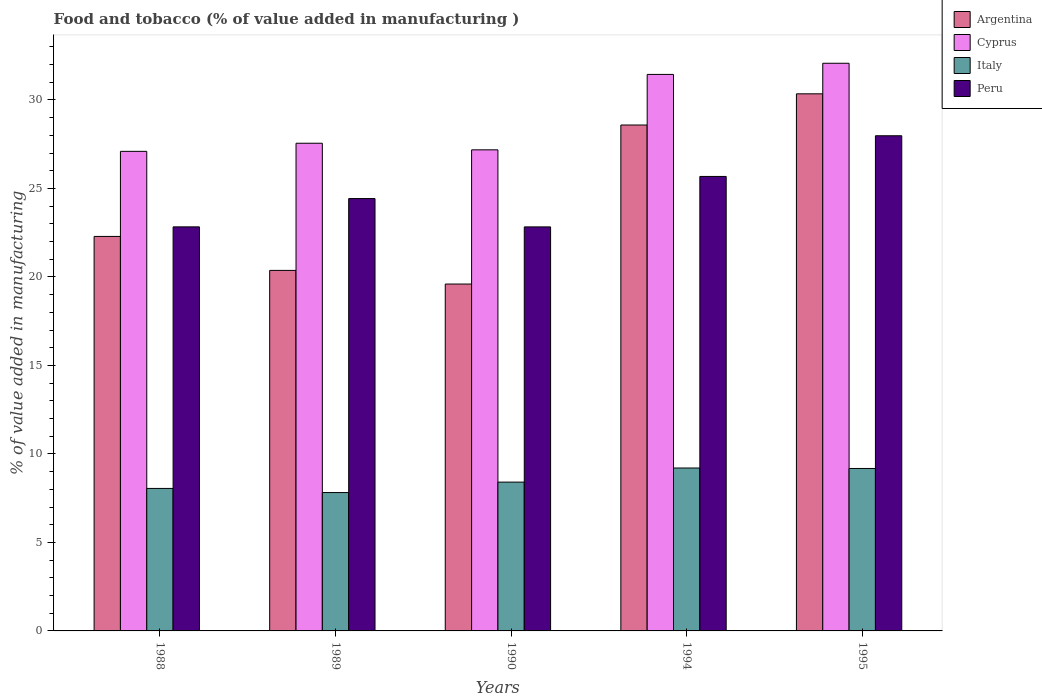How many groups of bars are there?
Your answer should be very brief. 5. Are the number of bars per tick equal to the number of legend labels?
Provide a succinct answer. Yes. Are the number of bars on each tick of the X-axis equal?
Provide a succinct answer. Yes. In how many cases, is the number of bars for a given year not equal to the number of legend labels?
Provide a short and direct response. 0. What is the value added in manufacturing food and tobacco in Argentina in 1989?
Provide a succinct answer. 20.37. Across all years, what is the maximum value added in manufacturing food and tobacco in Cyprus?
Provide a succinct answer. 32.07. Across all years, what is the minimum value added in manufacturing food and tobacco in Argentina?
Your response must be concise. 19.6. In which year was the value added in manufacturing food and tobacco in Peru maximum?
Provide a short and direct response. 1995. In which year was the value added in manufacturing food and tobacco in Cyprus minimum?
Your response must be concise. 1988. What is the total value added in manufacturing food and tobacco in Italy in the graph?
Your response must be concise. 42.66. What is the difference between the value added in manufacturing food and tobacco in Cyprus in 1988 and that in 1994?
Make the answer very short. -4.35. What is the difference between the value added in manufacturing food and tobacco in Peru in 1988 and the value added in manufacturing food and tobacco in Cyprus in 1995?
Provide a short and direct response. -9.24. What is the average value added in manufacturing food and tobacco in Cyprus per year?
Make the answer very short. 29.07. In the year 1995, what is the difference between the value added in manufacturing food and tobacco in Italy and value added in manufacturing food and tobacco in Argentina?
Provide a short and direct response. -21.17. What is the ratio of the value added in manufacturing food and tobacco in Cyprus in 1989 to that in 1995?
Your response must be concise. 0.86. What is the difference between the highest and the second highest value added in manufacturing food and tobacco in Cyprus?
Give a very brief answer. 0.63. What is the difference between the highest and the lowest value added in manufacturing food and tobacco in Peru?
Offer a very short reply. 5.15. What does the 1st bar from the left in 1990 represents?
Offer a terse response. Argentina. How many bars are there?
Offer a terse response. 20. Are all the bars in the graph horizontal?
Ensure brevity in your answer.  No. What is the title of the graph?
Ensure brevity in your answer.  Food and tobacco (% of value added in manufacturing ). Does "Rwanda" appear as one of the legend labels in the graph?
Your answer should be compact. No. What is the label or title of the Y-axis?
Keep it short and to the point. % of value added in manufacturing. What is the % of value added in manufacturing in Argentina in 1988?
Your answer should be very brief. 22.29. What is the % of value added in manufacturing in Cyprus in 1988?
Provide a succinct answer. 27.1. What is the % of value added in manufacturing of Italy in 1988?
Offer a terse response. 8.05. What is the % of value added in manufacturing in Peru in 1988?
Make the answer very short. 22.83. What is the % of value added in manufacturing of Argentina in 1989?
Ensure brevity in your answer.  20.37. What is the % of value added in manufacturing of Cyprus in 1989?
Offer a very short reply. 27.56. What is the % of value added in manufacturing of Italy in 1989?
Your answer should be compact. 7.82. What is the % of value added in manufacturing in Peru in 1989?
Keep it short and to the point. 24.43. What is the % of value added in manufacturing in Argentina in 1990?
Offer a very short reply. 19.6. What is the % of value added in manufacturing in Cyprus in 1990?
Provide a succinct answer. 27.18. What is the % of value added in manufacturing in Italy in 1990?
Ensure brevity in your answer.  8.41. What is the % of value added in manufacturing of Peru in 1990?
Provide a short and direct response. 22.83. What is the % of value added in manufacturing in Argentina in 1994?
Make the answer very short. 28.58. What is the % of value added in manufacturing of Cyprus in 1994?
Provide a short and direct response. 31.44. What is the % of value added in manufacturing of Italy in 1994?
Your answer should be very brief. 9.21. What is the % of value added in manufacturing in Peru in 1994?
Offer a terse response. 25.68. What is the % of value added in manufacturing of Argentina in 1995?
Offer a terse response. 30.35. What is the % of value added in manufacturing of Cyprus in 1995?
Your answer should be very brief. 32.07. What is the % of value added in manufacturing of Italy in 1995?
Give a very brief answer. 9.18. What is the % of value added in manufacturing in Peru in 1995?
Make the answer very short. 27.98. Across all years, what is the maximum % of value added in manufacturing of Argentina?
Your response must be concise. 30.35. Across all years, what is the maximum % of value added in manufacturing of Cyprus?
Offer a terse response. 32.07. Across all years, what is the maximum % of value added in manufacturing in Italy?
Offer a terse response. 9.21. Across all years, what is the maximum % of value added in manufacturing of Peru?
Provide a succinct answer. 27.98. Across all years, what is the minimum % of value added in manufacturing of Argentina?
Offer a very short reply. 19.6. Across all years, what is the minimum % of value added in manufacturing in Cyprus?
Offer a very short reply. 27.1. Across all years, what is the minimum % of value added in manufacturing of Italy?
Make the answer very short. 7.82. Across all years, what is the minimum % of value added in manufacturing in Peru?
Provide a succinct answer. 22.83. What is the total % of value added in manufacturing of Argentina in the graph?
Keep it short and to the point. 121.19. What is the total % of value added in manufacturing of Cyprus in the graph?
Your answer should be compact. 145.35. What is the total % of value added in manufacturing of Italy in the graph?
Your response must be concise. 42.66. What is the total % of value added in manufacturing of Peru in the graph?
Make the answer very short. 123.74. What is the difference between the % of value added in manufacturing of Argentina in 1988 and that in 1989?
Your response must be concise. 1.92. What is the difference between the % of value added in manufacturing of Cyprus in 1988 and that in 1989?
Provide a short and direct response. -0.46. What is the difference between the % of value added in manufacturing in Italy in 1988 and that in 1989?
Keep it short and to the point. 0.23. What is the difference between the % of value added in manufacturing of Argentina in 1988 and that in 1990?
Provide a short and direct response. 2.69. What is the difference between the % of value added in manufacturing in Cyprus in 1988 and that in 1990?
Make the answer very short. -0.09. What is the difference between the % of value added in manufacturing of Italy in 1988 and that in 1990?
Give a very brief answer. -0.36. What is the difference between the % of value added in manufacturing in Peru in 1988 and that in 1990?
Your answer should be very brief. 0. What is the difference between the % of value added in manufacturing of Argentina in 1988 and that in 1994?
Provide a succinct answer. -6.29. What is the difference between the % of value added in manufacturing of Cyprus in 1988 and that in 1994?
Provide a short and direct response. -4.35. What is the difference between the % of value added in manufacturing of Italy in 1988 and that in 1994?
Offer a very short reply. -1.15. What is the difference between the % of value added in manufacturing of Peru in 1988 and that in 1994?
Give a very brief answer. -2.85. What is the difference between the % of value added in manufacturing in Argentina in 1988 and that in 1995?
Provide a short and direct response. -8.06. What is the difference between the % of value added in manufacturing of Cyprus in 1988 and that in 1995?
Provide a succinct answer. -4.98. What is the difference between the % of value added in manufacturing in Italy in 1988 and that in 1995?
Offer a very short reply. -1.13. What is the difference between the % of value added in manufacturing in Peru in 1988 and that in 1995?
Make the answer very short. -5.15. What is the difference between the % of value added in manufacturing in Argentina in 1989 and that in 1990?
Your answer should be compact. 0.77. What is the difference between the % of value added in manufacturing of Cyprus in 1989 and that in 1990?
Offer a terse response. 0.37. What is the difference between the % of value added in manufacturing of Italy in 1989 and that in 1990?
Ensure brevity in your answer.  -0.59. What is the difference between the % of value added in manufacturing in Peru in 1989 and that in 1990?
Provide a short and direct response. 1.6. What is the difference between the % of value added in manufacturing in Argentina in 1989 and that in 1994?
Provide a short and direct response. -8.21. What is the difference between the % of value added in manufacturing in Cyprus in 1989 and that in 1994?
Provide a succinct answer. -3.89. What is the difference between the % of value added in manufacturing in Italy in 1989 and that in 1994?
Keep it short and to the point. -1.39. What is the difference between the % of value added in manufacturing in Peru in 1989 and that in 1994?
Give a very brief answer. -1.25. What is the difference between the % of value added in manufacturing in Argentina in 1989 and that in 1995?
Make the answer very short. -9.98. What is the difference between the % of value added in manufacturing in Cyprus in 1989 and that in 1995?
Provide a short and direct response. -4.52. What is the difference between the % of value added in manufacturing of Italy in 1989 and that in 1995?
Offer a terse response. -1.36. What is the difference between the % of value added in manufacturing in Peru in 1989 and that in 1995?
Your answer should be compact. -3.55. What is the difference between the % of value added in manufacturing of Argentina in 1990 and that in 1994?
Your answer should be very brief. -8.98. What is the difference between the % of value added in manufacturing of Cyprus in 1990 and that in 1994?
Your response must be concise. -4.26. What is the difference between the % of value added in manufacturing of Italy in 1990 and that in 1994?
Your response must be concise. -0.8. What is the difference between the % of value added in manufacturing of Peru in 1990 and that in 1994?
Your answer should be very brief. -2.85. What is the difference between the % of value added in manufacturing of Argentina in 1990 and that in 1995?
Keep it short and to the point. -10.75. What is the difference between the % of value added in manufacturing in Cyprus in 1990 and that in 1995?
Provide a short and direct response. -4.89. What is the difference between the % of value added in manufacturing in Italy in 1990 and that in 1995?
Give a very brief answer. -0.77. What is the difference between the % of value added in manufacturing in Peru in 1990 and that in 1995?
Give a very brief answer. -5.15. What is the difference between the % of value added in manufacturing in Argentina in 1994 and that in 1995?
Ensure brevity in your answer.  -1.76. What is the difference between the % of value added in manufacturing of Cyprus in 1994 and that in 1995?
Your answer should be very brief. -0.63. What is the difference between the % of value added in manufacturing in Italy in 1994 and that in 1995?
Your answer should be compact. 0.03. What is the difference between the % of value added in manufacturing of Peru in 1994 and that in 1995?
Offer a terse response. -2.3. What is the difference between the % of value added in manufacturing in Argentina in 1988 and the % of value added in manufacturing in Cyprus in 1989?
Offer a very short reply. -5.27. What is the difference between the % of value added in manufacturing of Argentina in 1988 and the % of value added in manufacturing of Italy in 1989?
Give a very brief answer. 14.47. What is the difference between the % of value added in manufacturing of Argentina in 1988 and the % of value added in manufacturing of Peru in 1989?
Ensure brevity in your answer.  -2.14. What is the difference between the % of value added in manufacturing in Cyprus in 1988 and the % of value added in manufacturing in Italy in 1989?
Your answer should be compact. 19.28. What is the difference between the % of value added in manufacturing of Cyprus in 1988 and the % of value added in manufacturing of Peru in 1989?
Your answer should be very brief. 2.67. What is the difference between the % of value added in manufacturing of Italy in 1988 and the % of value added in manufacturing of Peru in 1989?
Offer a terse response. -16.38. What is the difference between the % of value added in manufacturing of Argentina in 1988 and the % of value added in manufacturing of Cyprus in 1990?
Your answer should be compact. -4.89. What is the difference between the % of value added in manufacturing in Argentina in 1988 and the % of value added in manufacturing in Italy in 1990?
Make the answer very short. 13.88. What is the difference between the % of value added in manufacturing of Argentina in 1988 and the % of value added in manufacturing of Peru in 1990?
Ensure brevity in your answer.  -0.54. What is the difference between the % of value added in manufacturing of Cyprus in 1988 and the % of value added in manufacturing of Italy in 1990?
Provide a succinct answer. 18.69. What is the difference between the % of value added in manufacturing in Cyprus in 1988 and the % of value added in manufacturing in Peru in 1990?
Provide a short and direct response. 4.27. What is the difference between the % of value added in manufacturing of Italy in 1988 and the % of value added in manufacturing of Peru in 1990?
Keep it short and to the point. -14.78. What is the difference between the % of value added in manufacturing of Argentina in 1988 and the % of value added in manufacturing of Cyprus in 1994?
Provide a succinct answer. -9.15. What is the difference between the % of value added in manufacturing of Argentina in 1988 and the % of value added in manufacturing of Italy in 1994?
Make the answer very short. 13.08. What is the difference between the % of value added in manufacturing in Argentina in 1988 and the % of value added in manufacturing in Peru in 1994?
Ensure brevity in your answer.  -3.39. What is the difference between the % of value added in manufacturing of Cyprus in 1988 and the % of value added in manufacturing of Italy in 1994?
Provide a succinct answer. 17.89. What is the difference between the % of value added in manufacturing of Cyprus in 1988 and the % of value added in manufacturing of Peru in 1994?
Give a very brief answer. 1.42. What is the difference between the % of value added in manufacturing of Italy in 1988 and the % of value added in manufacturing of Peru in 1994?
Ensure brevity in your answer.  -17.63. What is the difference between the % of value added in manufacturing of Argentina in 1988 and the % of value added in manufacturing of Cyprus in 1995?
Provide a succinct answer. -9.78. What is the difference between the % of value added in manufacturing of Argentina in 1988 and the % of value added in manufacturing of Italy in 1995?
Your answer should be very brief. 13.11. What is the difference between the % of value added in manufacturing in Argentina in 1988 and the % of value added in manufacturing in Peru in 1995?
Your answer should be compact. -5.69. What is the difference between the % of value added in manufacturing of Cyprus in 1988 and the % of value added in manufacturing of Italy in 1995?
Provide a succinct answer. 17.92. What is the difference between the % of value added in manufacturing in Cyprus in 1988 and the % of value added in manufacturing in Peru in 1995?
Your response must be concise. -0.88. What is the difference between the % of value added in manufacturing of Italy in 1988 and the % of value added in manufacturing of Peru in 1995?
Keep it short and to the point. -19.93. What is the difference between the % of value added in manufacturing of Argentina in 1989 and the % of value added in manufacturing of Cyprus in 1990?
Keep it short and to the point. -6.81. What is the difference between the % of value added in manufacturing in Argentina in 1989 and the % of value added in manufacturing in Italy in 1990?
Your response must be concise. 11.96. What is the difference between the % of value added in manufacturing in Argentina in 1989 and the % of value added in manufacturing in Peru in 1990?
Offer a terse response. -2.46. What is the difference between the % of value added in manufacturing in Cyprus in 1989 and the % of value added in manufacturing in Italy in 1990?
Ensure brevity in your answer.  19.15. What is the difference between the % of value added in manufacturing of Cyprus in 1989 and the % of value added in manufacturing of Peru in 1990?
Offer a very short reply. 4.73. What is the difference between the % of value added in manufacturing of Italy in 1989 and the % of value added in manufacturing of Peru in 1990?
Keep it short and to the point. -15.01. What is the difference between the % of value added in manufacturing in Argentina in 1989 and the % of value added in manufacturing in Cyprus in 1994?
Provide a short and direct response. -11.07. What is the difference between the % of value added in manufacturing in Argentina in 1989 and the % of value added in manufacturing in Italy in 1994?
Give a very brief answer. 11.16. What is the difference between the % of value added in manufacturing of Argentina in 1989 and the % of value added in manufacturing of Peru in 1994?
Keep it short and to the point. -5.31. What is the difference between the % of value added in manufacturing in Cyprus in 1989 and the % of value added in manufacturing in Italy in 1994?
Provide a short and direct response. 18.35. What is the difference between the % of value added in manufacturing in Cyprus in 1989 and the % of value added in manufacturing in Peru in 1994?
Your response must be concise. 1.88. What is the difference between the % of value added in manufacturing in Italy in 1989 and the % of value added in manufacturing in Peru in 1994?
Ensure brevity in your answer.  -17.86. What is the difference between the % of value added in manufacturing in Argentina in 1989 and the % of value added in manufacturing in Cyprus in 1995?
Provide a succinct answer. -11.7. What is the difference between the % of value added in manufacturing in Argentina in 1989 and the % of value added in manufacturing in Italy in 1995?
Your response must be concise. 11.19. What is the difference between the % of value added in manufacturing of Argentina in 1989 and the % of value added in manufacturing of Peru in 1995?
Ensure brevity in your answer.  -7.61. What is the difference between the % of value added in manufacturing of Cyprus in 1989 and the % of value added in manufacturing of Italy in 1995?
Offer a terse response. 18.38. What is the difference between the % of value added in manufacturing of Cyprus in 1989 and the % of value added in manufacturing of Peru in 1995?
Give a very brief answer. -0.42. What is the difference between the % of value added in manufacturing of Italy in 1989 and the % of value added in manufacturing of Peru in 1995?
Make the answer very short. -20.16. What is the difference between the % of value added in manufacturing in Argentina in 1990 and the % of value added in manufacturing in Cyprus in 1994?
Ensure brevity in your answer.  -11.84. What is the difference between the % of value added in manufacturing in Argentina in 1990 and the % of value added in manufacturing in Italy in 1994?
Give a very brief answer. 10.39. What is the difference between the % of value added in manufacturing of Argentina in 1990 and the % of value added in manufacturing of Peru in 1994?
Your answer should be very brief. -6.08. What is the difference between the % of value added in manufacturing in Cyprus in 1990 and the % of value added in manufacturing in Italy in 1994?
Your response must be concise. 17.98. What is the difference between the % of value added in manufacturing of Cyprus in 1990 and the % of value added in manufacturing of Peru in 1994?
Offer a very short reply. 1.5. What is the difference between the % of value added in manufacturing in Italy in 1990 and the % of value added in manufacturing in Peru in 1994?
Your answer should be compact. -17.27. What is the difference between the % of value added in manufacturing of Argentina in 1990 and the % of value added in manufacturing of Cyprus in 1995?
Offer a terse response. -12.47. What is the difference between the % of value added in manufacturing of Argentina in 1990 and the % of value added in manufacturing of Italy in 1995?
Ensure brevity in your answer.  10.42. What is the difference between the % of value added in manufacturing of Argentina in 1990 and the % of value added in manufacturing of Peru in 1995?
Keep it short and to the point. -8.38. What is the difference between the % of value added in manufacturing of Cyprus in 1990 and the % of value added in manufacturing of Italy in 1995?
Give a very brief answer. 18. What is the difference between the % of value added in manufacturing of Cyprus in 1990 and the % of value added in manufacturing of Peru in 1995?
Your answer should be compact. -0.8. What is the difference between the % of value added in manufacturing in Italy in 1990 and the % of value added in manufacturing in Peru in 1995?
Provide a short and direct response. -19.57. What is the difference between the % of value added in manufacturing of Argentina in 1994 and the % of value added in manufacturing of Cyprus in 1995?
Your answer should be very brief. -3.49. What is the difference between the % of value added in manufacturing of Argentina in 1994 and the % of value added in manufacturing of Italy in 1995?
Your answer should be compact. 19.41. What is the difference between the % of value added in manufacturing in Argentina in 1994 and the % of value added in manufacturing in Peru in 1995?
Offer a terse response. 0.61. What is the difference between the % of value added in manufacturing of Cyprus in 1994 and the % of value added in manufacturing of Italy in 1995?
Your answer should be very brief. 22.27. What is the difference between the % of value added in manufacturing in Cyprus in 1994 and the % of value added in manufacturing in Peru in 1995?
Keep it short and to the point. 3.47. What is the difference between the % of value added in manufacturing of Italy in 1994 and the % of value added in manufacturing of Peru in 1995?
Offer a terse response. -18.77. What is the average % of value added in manufacturing in Argentina per year?
Ensure brevity in your answer.  24.24. What is the average % of value added in manufacturing of Cyprus per year?
Your answer should be compact. 29.07. What is the average % of value added in manufacturing of Italy per year?
Provide a short and direct response. 8.53. What is the average % of value added in manufacturing of Peru per year?
Your answer should be very brief. 24.75. In the year 1988, what is the difference between the % of value added in manufacturing of Argentina and % of value added in manufacturing of Cyprus?
Offer a very short reply. -4.81. In the year 1988, what is the difference between the % of value added in manufacturing in Argentina and % of value added in manufacturing in Italy?
Ensure brevity in your answer.  14.24. In the year 1988, what is the difference between the % of value added in manufacturing of Argentina and % of value added in manufacturing of Peru?
Your answer should be compact. -0.54. In the year 1988, what is the difference between the % of value added in manufacturing of Cyprus and % of value added in manufacturing of Italy?
Give a very brief answer. 19.05. In the year 1988, what is the difference between the % of value added in manufacturing of Cyprus and % of value added in manufacturing of Peru?
Provide a succinct answer. 4.27. In the year 1988, what is the difference between the % of value added in manufacturing in Italy and % of value added in manufacturing in Peru?
Make the answer very short. -14.78. In the year 1989, what is the difference between the % of value added in manufacturing of Argentina and % of value added in manufacturing of Cyprus?
Your response must be concise. -7.19. In the year 1989, what is the difference between the % of value added in manufacturing in Argentina and % of value added in manufacturing in Italy?
Offer a terse response. 12.55. In the year 1989, what is the difference between the % of value added in manufacturing of Argentina and % of value added in manufacturing of Peru?
Your response must be concise. -4.06. In the year 1989, what is the difference between the % of value added in manufacturing in Cyprus and % of value added in manufacturing in Italy?
Provide a short and direct response. 19.74. In the year 1989, what is the difference between the % of value added in manufacturing of Cyprus and % of value added in manufacturing of Peru?
Provide a short and direct response. 3.13. In the year 1989, what is the difference between the % of value added in manufacturing in Italy and % of value added in manufacturing in Peru?
Provide a short and direct response. -16.61. In the year 1990, what is the difference between the % of value added in manufacturing in Argentina and % of value added in manufacturing in Cyprus?
Make the answer very short. -7.58. In the year 1990, what is the difference between the % of value added in manufacturing in Argentina and % of value added in manufacturing in Italy?
Give a very brief answer. 11.19. In the year 1990, what is the difference between the % of value added in manufacturing in Argentina and % of value added in manufacturing in Peru?
Provide a succinct answer. -3.23. In the year 1990, what is the difference between the % of value added in manufacturing in Cyprus and % of value added in manufacturing in Italy?
Your response must be concise. 18.77. In the year 1990, what is the difference between the % of value added in manufacturing of Cyprus and % of value added in manufacturing of Peru?
Offer a terse response. 4.35. In the year 1990, what is the difference between the % of value added in manufacturing in Italy and % of value added in manufacturing in Peru?
Your response must be concise. -14.42. In the year 1994, what is the difference between the % of value added in manufacturing in Argentina and % of value added in manufacturing in Cyprus?
Keep it short and to the point. -2.86. In the year 1994, what is the difference between the % of value added in manufacturing of Argentina and % of value added in manufacturing of Italy?
Keep it short and to the point. 19.38. In the year 1994, what is the difference between the % of value added in manufacturing in Argentina and % of value added in manufacturing in Peru?
Make the answer very short. 2.91. In the year 1994, what is the difference between the % of value added in manufacturing in Cyprus and % of value added in manufacturing in Italy?
Keep it short and to the point. 22.24. In the year 1994, what is the difference between the % of value added in manufacturing of Cyprus and % of value added in manufacturing of Peru?
Ensure brevity in your answer.  5.76. In the year 1994, what is the difference between the % of value added in manufacturing of Italy and % of value added in manufacturing of Peru?
Ensure brevity in your answer.  -16.47. In the year 1995, what is the difference between the % of value added in manufacturing of Argentina and % of value added in manufacturing of Cyprus?
Your response must be concise. -1.73. In the year 1995, what is the difference between the % of value added in manufacturing of Argentina and % of value added in manufacturing of Italy?
Make the answer very short. 21.17. In the year 1995, what is the difference between the % of value added in manufacturing in Argentina and % of value added in manufacturing in Peru?
Ensure brevity in your answer.  2.37. In the year 1995, what is the difference between the % of value added in manufacturing in Cyprus and % of value added in manufacturing in Italy?
Offer a very short reply. 22.9. In the year 1995, what is the difference between the % of value added in manufacturing of Cyprus and % of value added in manufacturing of Peru?
Make the answer very short. 4.1. In the year 1995, what is the difference between the % of value added in manufacturing of Italy and % of value added in manufacturing of Peru?
Offer a very short reply. -18.8. What is the ratio of the % of value added in manufacturing in Argentina in 1988 to that in 1989?
Your answer should be compact. 1.09. What is the ratio of the % of value added in manufacturing of Cyprus in 1988 to that in 1989?
Provide a short and direct response. 0.98. What is the ratio of the % of value added in manufacturing in Italy in 1988 to that in 1989?
Your answer should be very brief. 1.03. What is the ratio of the % of value added in manufacturing in Peru in 1988 to that in 1989?
Your response must be concise. 0.93. What is the ratio of the % of value added in manufacturing in Argentina in 1988 to that in 1990?
Your answer should be compact. 1.14. What is the ratio of the % of value added in manufacturing in Cyprus in 1988 to that in 1990?
Your answer should be compact. 1. What is the ratio of the % of value added in manufacturing of Italy in 1988 to that in 1990?
Provide a short and direct response. 0.96. What is the ratio of the % of value added in manufacturing of Peru in 1988 to that in 1990?
Offer a very short reply. 1. What is the ratio of the % of value added in manufacturing of Argentina in 1988 to that in 1994?
Offer a very short reply. 0.78. What is the ratio of the % of value added in manufacturing of Cyprus in 1988 to that in 1994?
Keep it short and to the point. 0.86. What is the ratio of the % of value added in manufacturing of Italy in 1988 to that in 1994?
Ensure brevity in your answer.  0.87. What is the ratio of the % of value added in manufacturing in Peru in 1988 to that in 1994?
Provide a succinct answer. 0.89. What is the ratio of the % of value added in manufacturing of Argentina in 1988 to that in 1995?
Your answer should be very brief. 0.73. What is the ratio of the % of value added in manufacturing of Cyprus in 1988 to that in 1995?
Your answer should be compact. 0.84. What is the ratio of the % of value added in manufacturing of Italy in 1988 to that in 1995?
Offer a very short reply. 0.88. What is the ratio of the % of value added in manufacturing of Peru in 1988 to that in 1995?
Offer a very short reply. 0.82. What is the ratio of the % of value added in manufacturing of Argentina in 1989 to that in 1990?
Offer a very short reply. 1.04. What is the ratio of the % of value added in manufacturing in Cyprus in 1989 to that in 1990?
Your answer should be very brief. 1.01. What is the ratio of the % of value added in manufacturing of Italy in 1989 to that in 1990?
Your answer should be very brief. 0.93. What is the ratio of the % of value added in manufacturing in Peru in 1989 to that in 1990?
Provide a short and direct response. 1.07. What is the ratio of the % of value added in manufacturing in Argentina in 1989 to that in 1994?
Provide a short and direct response. 0.71. What is the ratio of the % of value added in manufacturing of Cyprus in 1989 to that in 1994?
Give a very brief answer. 0.88. What is the ratio of the % of value added in manufacturing of Italy in 1989 to that in 1994?
Offer a very short reply. 0.85. What is the ratio of the % of value added in manufacturing in Peru in 1989 to that in 1994?
Offer a terse response. 0.95. What is the ratio of the % of value added in manufacturing of Argentina in 1989 to that in 1995?
Offer a very short reply. 0.67. What is the ratio of the % of value added in manufacturing of Cyprus in 1989 to that in 1995?
Ensure brevity in your answer.  0.86. What is the ratio of the % of value added in manufacturing in Italy in 1989 to that in 1995?
Keep it short and to the point. 0.85. What is the ratio of the % of value added in manufacturing in Peru in 1989 to that in 1995?
Offer a very short reply. 0.87. What is the ratio of the % of value added in manufacturing in Argentina in 1990 to that in 1994?
Keep it short and to the point. 0.69. What is the ratio of the % of value added in manufacturing in Cyprus in 1990 to that in 1994?
Offer a very short reply. 0.86. What is the ratio of the % of value added in manufacturing of Italy in 1990 to that in 1994?
Your answer should be compact. 0.91. What is the ratio of the % of value added in manufacturing of Peru in 1990 to that in 1994?
Your answer should be very brief. 0.89. What is the ratio of the % of value added in manufacturing of Argentina in 1990 to that in 1995?
Your answer should be very brief. 0.65. What is the ratio of the % of value added in manufacturing in Cyprus in 1990 to that in 1995?
Ensure brevity in your answer.  0.85. What is the ratio of the % of value added in manufacturing of Italy in 1990 to that in 1995?
Provide a short and direct response. 0.92. What is the ratio of the % of value added in manufacturing in Peru in 1990 to that in 1995?
Offer a terse response. 0.82. What is the ratio of the % of value added in manufacturing in Argentina in 1994 to that in 1995?
Offer a very short reply. 0.94. What is the ratio of the % of value added in manufacturing of Cyprus in 1994 to that in 1995?
Keep it short and to the point. 0.98. What is the ratio of the % of value added in manufacturing in Peru in 1994 to that in 1995?
Ensure brevity in your answer.  0.92. What is the difference between the highest and the second highest % of value added in manufacturing of Argentina?
Make the answer very short. 1.76. What is the difference between the highest and the second highest % of value added in manufacturing of Cyprus?
Keep it short and to the point. 0.63. What is the difference between the highest and the second highest % of value added in manufacturing of Italy?
Keep it short and to the point. 0.03. What is the difference between the highest and the second highest % of value added in manufacturing of Peru?
Ensure brevity in your answer.  2.3. What is the difference between the highest and the lowest % of value added in manufacturing in Argentina?
Provide a succinct answer. 10.75. What is the difference between the highest and the lowest % of value added in manufacturing of Cyprus?
Provide a short and direct response. 4.98. What is the difference between the highest and the lowest % of value added in manufacturing in Italy?
Offer a very short reply. 1.39. What is the difference between the highest and the lowest % of value added in manufacturing of Peru?
Offer a terse response. 5.15. 